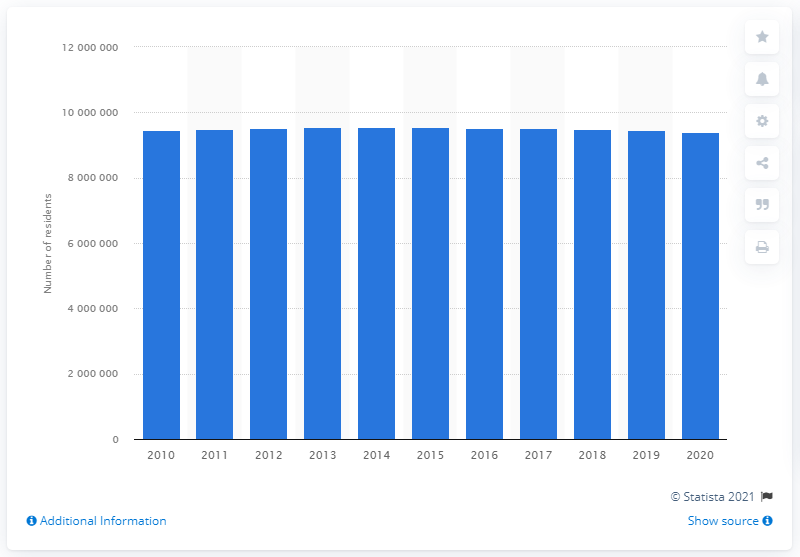Draw attention to some important aspects in this diagram. In 2020, the population of the Chicago-Naperville-Elgin metropolitan area was approximately 9,470,661. The population of the Chicago-Naperville-Elgin metropolitan area in the previous year was approximately 9,470,661. 